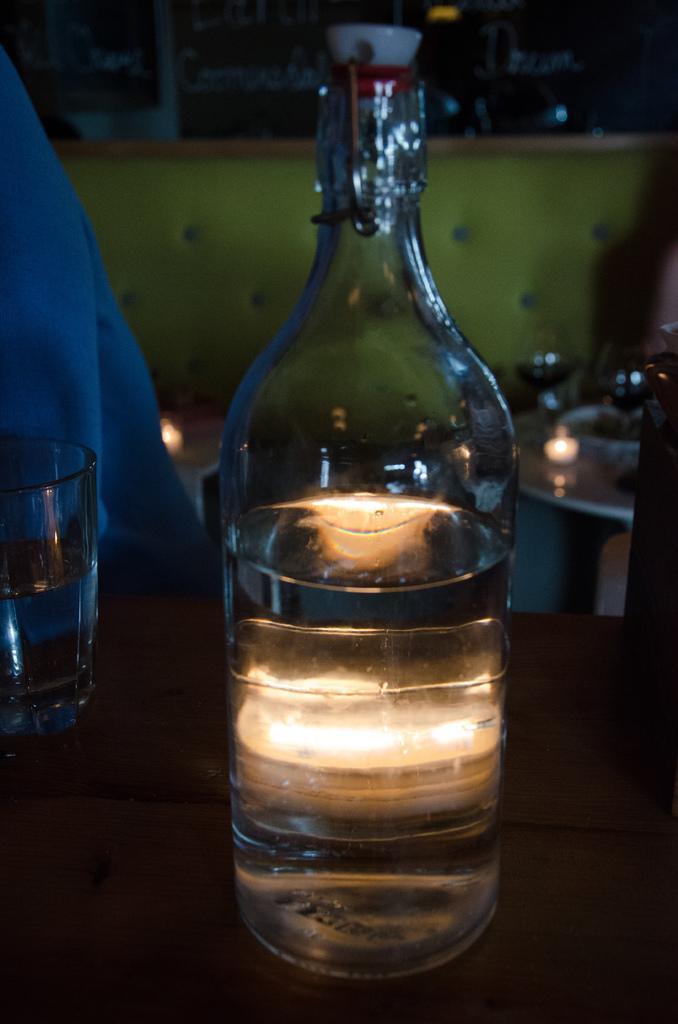Describe this image in one or two sentences. A glass bottle with some liquid in it and a glass are on a table. 